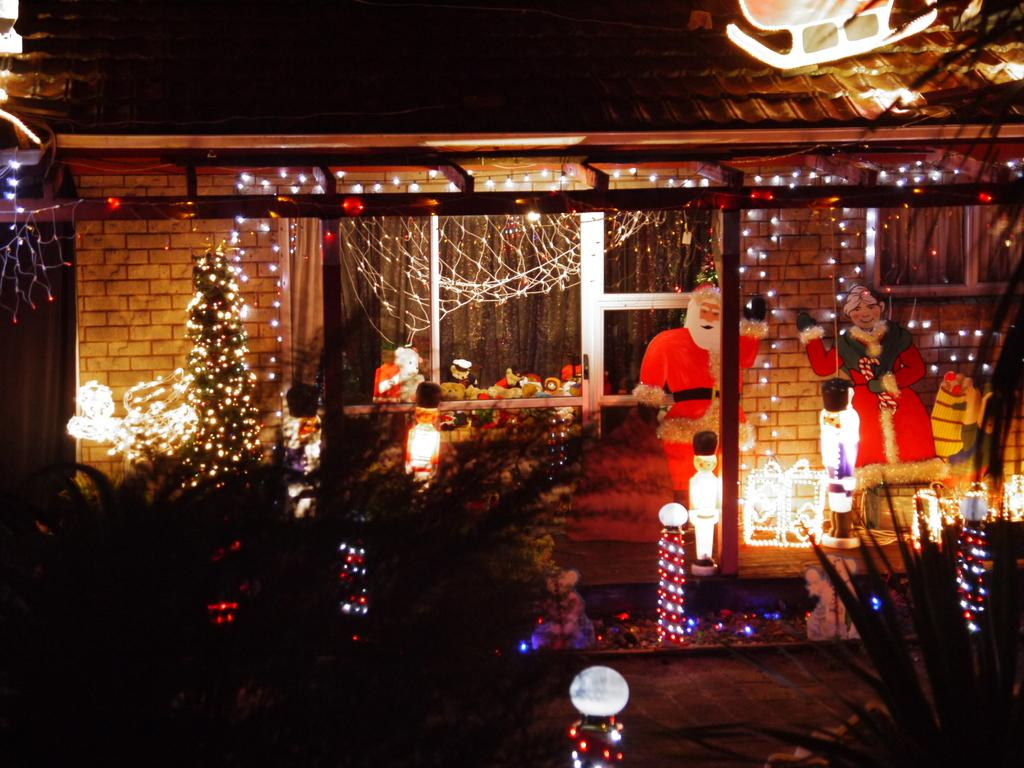What type of structure is visible in the image? There is a building in the image. What seasonal decoration can be seen inside the building? There is a Christmas tree in the building. What type of illumination is present in the building? There are lights in the building. What type of wall decorations are present in the building? There are pictures in the building. What type of vegetation is present in front of the building? There are plants in front of the building. How many pigs are visible in the image? There are no pigs present in the image. Can you tell me if the boy in the image is allergic to the plants? There is no boy present in the image, so it is not possible to determine if he is allergic to the plants. 